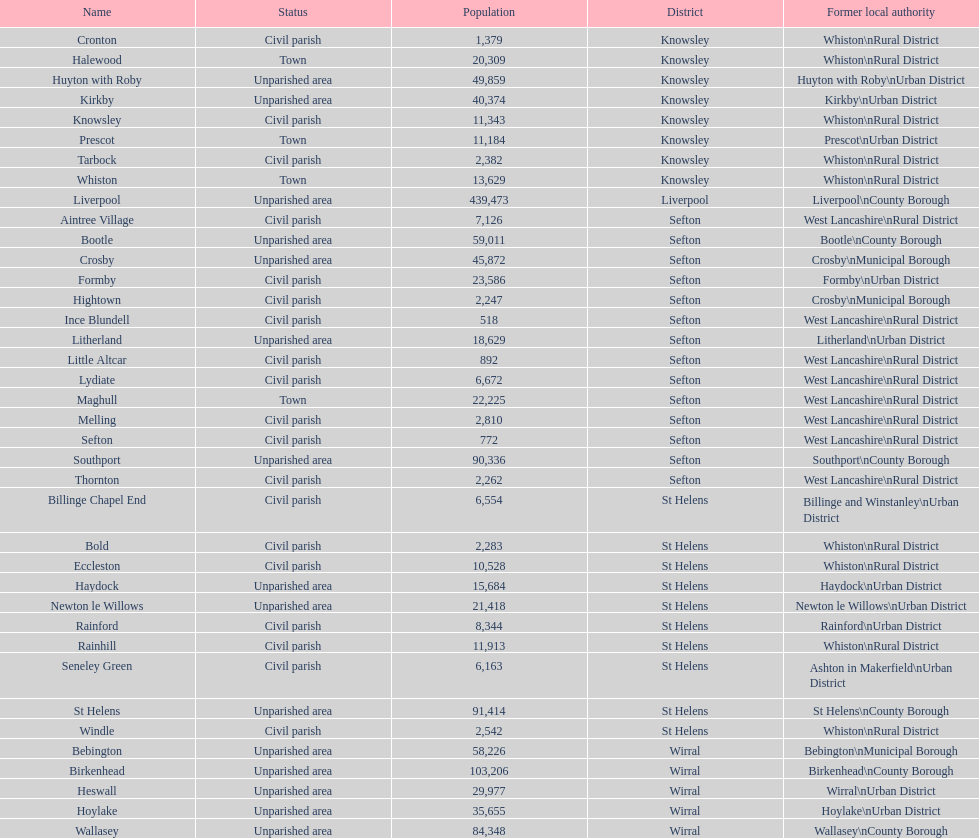What is the most populous area? Liverpool. 